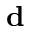Convert formula to latex. <formula><loc_0><loc_0><loc_500><loc_500>d</formula> 